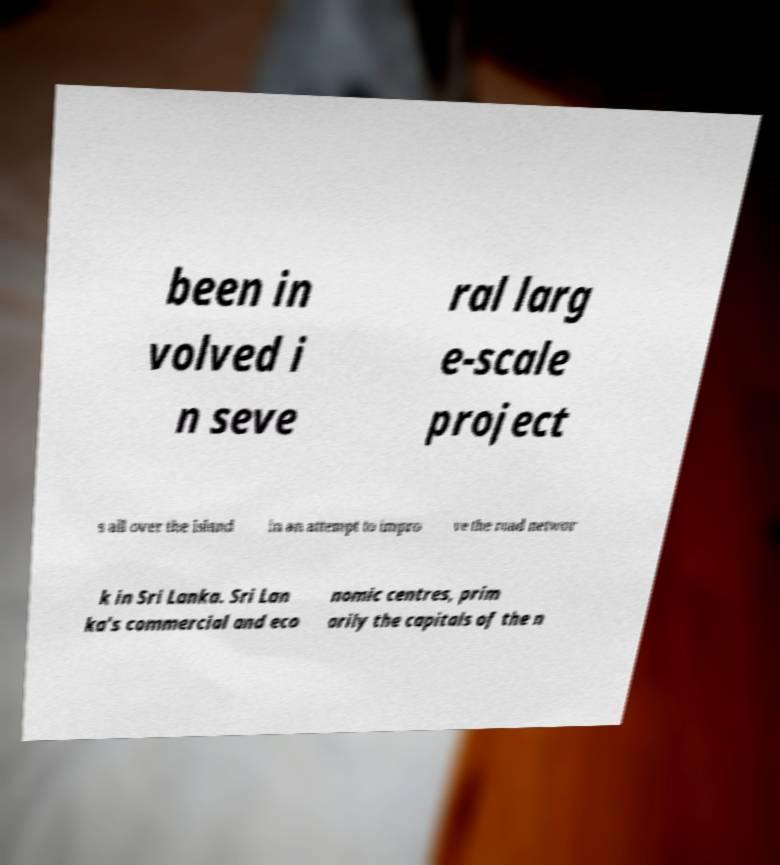Please read and relay the text visible in this image. What does it say? been in volved i n seve ral larg e-scale project s all over the island in an attempt to impro ve the road networ k in Sri Lanka. Sri Lan ka's commercial and eco nomic centres, prim arily the capitals of the n 